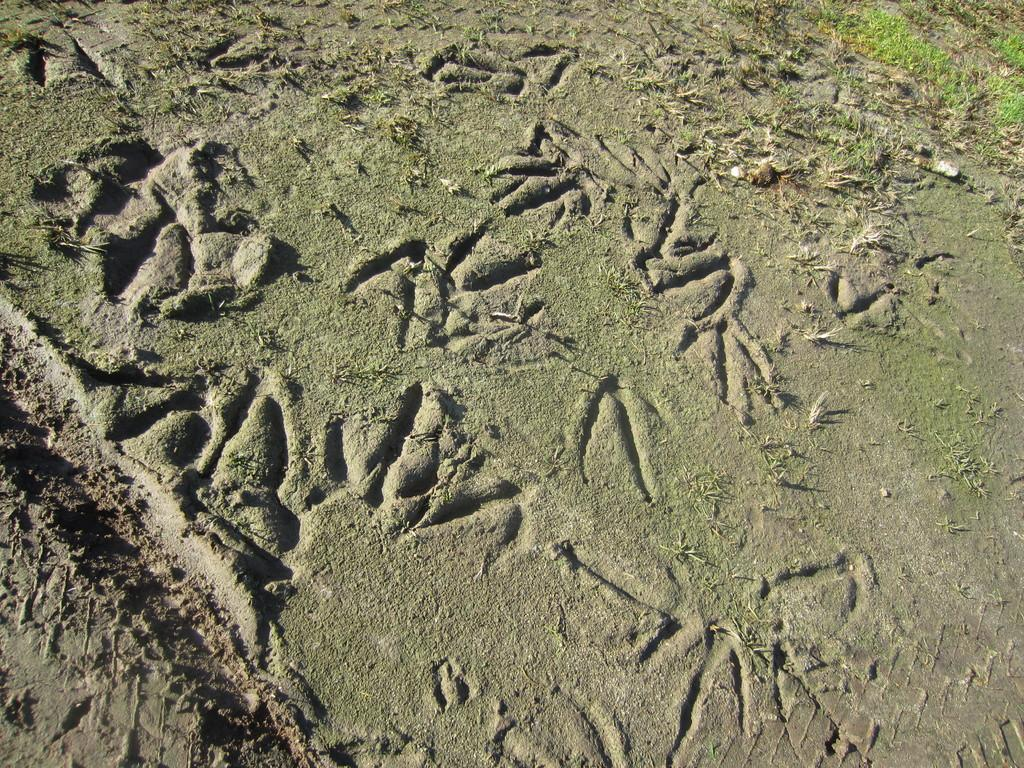What material is the floor made of in the image? The floor in the image is made of sand. Are there any zebras visible in the image? No, there are no zebras present in the image. Is there a game being played on the sand floor in the image? The image does not show any game being played; it only shows a sand floor. 